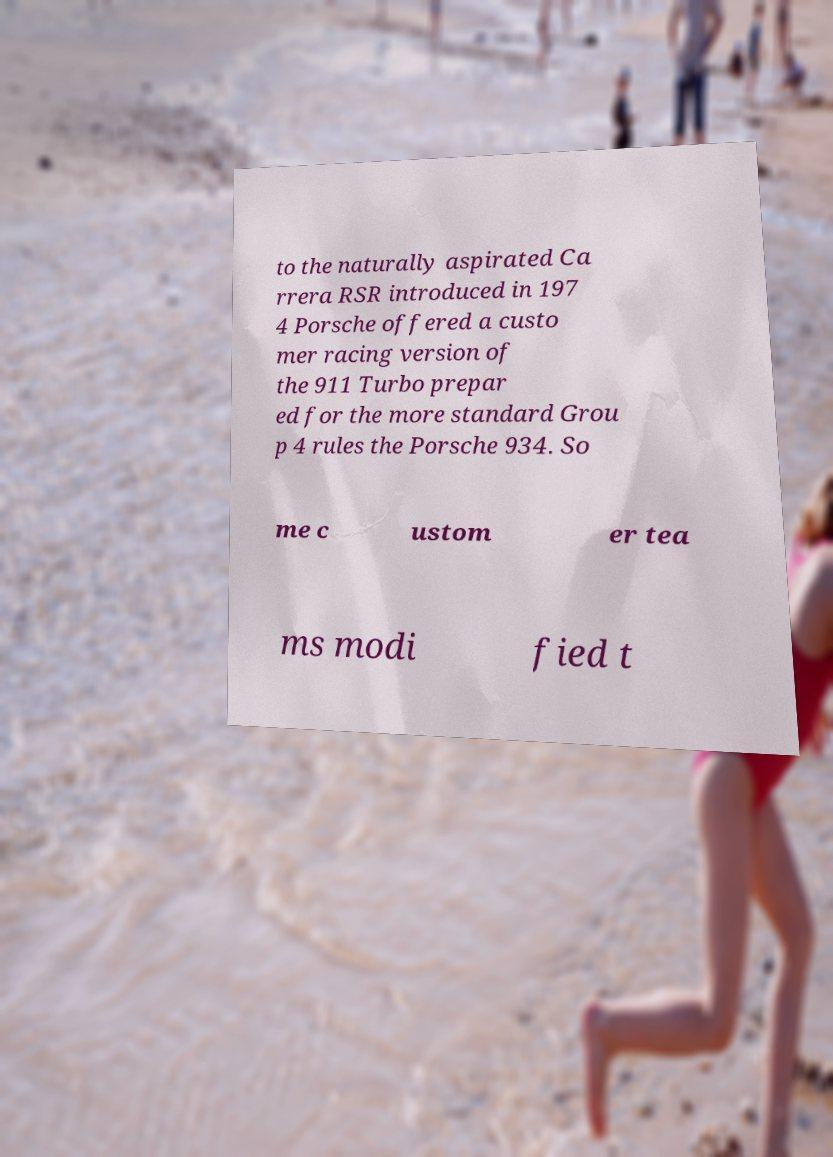Can you read and provide the text displayed in the image?This photo seems to have some interesting text. Can you extract and type it out for me? to the naturally aspirated Ca rrera RSR introduced in 197 4 Porsche offered a custo mer racing version of the 911 Turbo prepar ed for the more standard Grou p 4 rules the Porsche 934. So me c ustom er tea ms modi fied t 